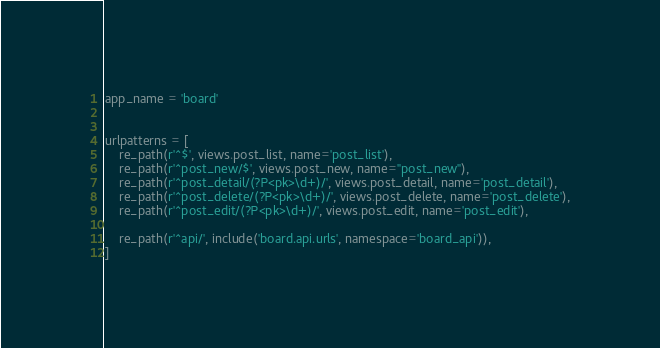Convert code to text. <code><loc_0><loc_0><loc_500><loc_500><_Python_>
app_name = 'board'


urlpatterns = [
    re_path(r'^$', views.post_list, name='post_list'),
    re_path(r'^post_new/$', views.post_new, name="post_new"),
    re_path(r'^post_detail/(?P<pk>\d+)/', views.post_detail, name='post_detail'),
    re_path(r'^post_delete/(?P<pk>\d+)/', views.post_delete, name='post_delete'),
    re_path(r'^post_edit/(?P<pk>\d+)/', views.post_edit, name='post_edit'),

    re_path(r'^api/', include('board.api.urls', namespace='board_api')),
]</code> 